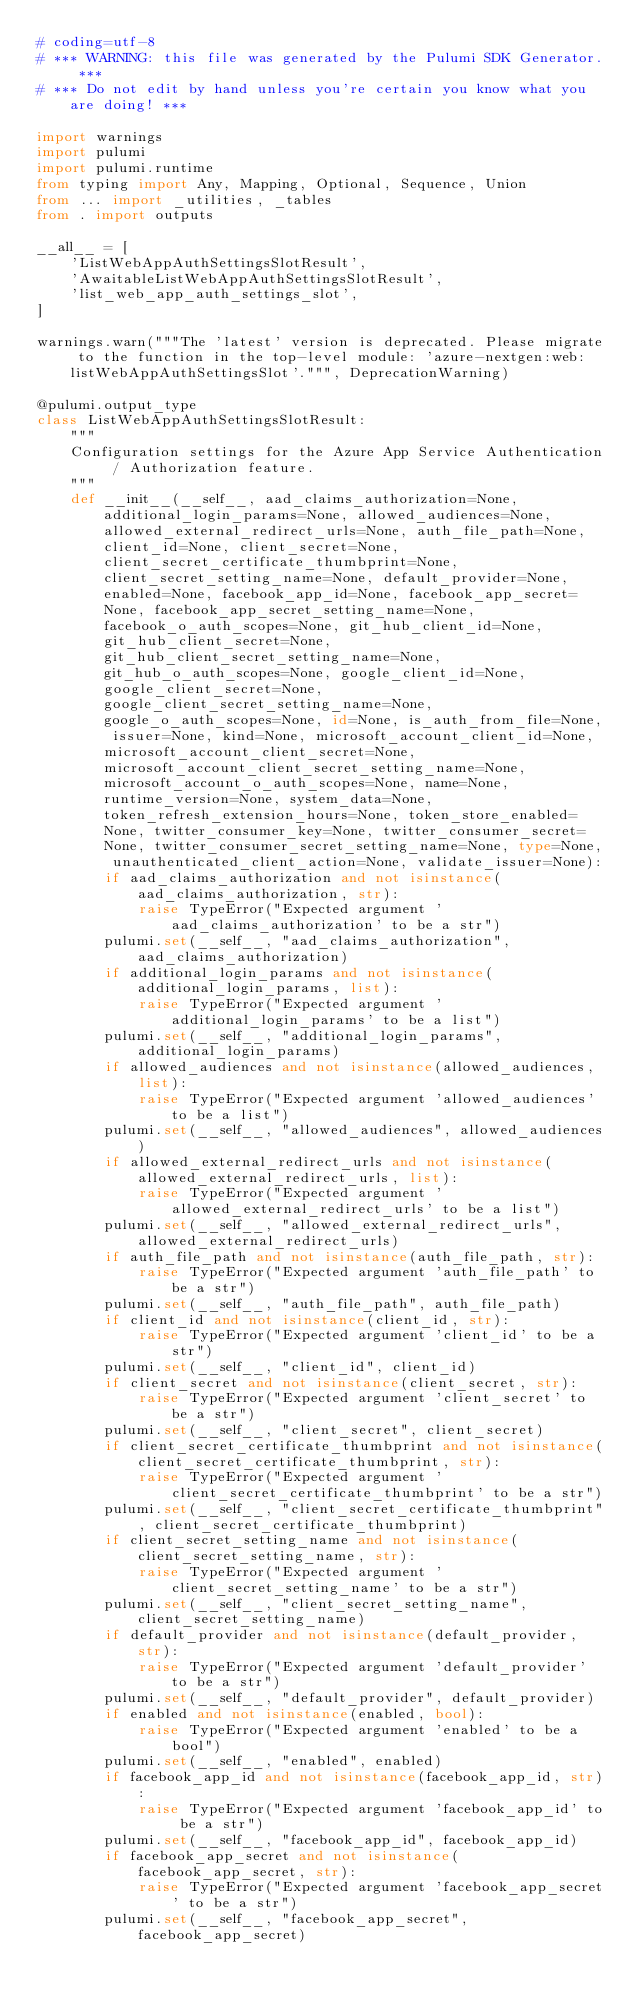<code> <loc_0><loc_0><loc_500><loc_500><_Python_># coding=utf-8
# *** WARNING: this file was generated by the Pulumi SDK Generator. ***
# *** Do not edit by hand unless you're certain you know what you are doing! ***

import warnings
import pulumi
import pulumi.runtime
from typing import Any, Mapping, Optional, Sequence, Union
from ... import _utilities, _tables
from . import outputs

__all__ = [
    'ListWebAppAuthSettingsSlotResult',
    'AwaitableListWebAppAuthSettingsSlotResult',
    'list_web_app_auth_settings_slot',
]

warnings.warn("""The 'latest' version is deprecated. Please migrate to the function in the top-level module: 'azure-nextgen:web:listWebAppAuthSettingsSlot'.""", DeprecationWarning)

@pulumi.output_type
class ListWebAppAuthSettingsSlotResult:
    """
    Configuration settings for the Azure App Service Authentication / Authorization feature.
    """
    def __init__(__self__, aad_claims_authorization=None, additional_login_params=None, allowed_audiences=None, allowed_external_redirect_urls=None, auth_file_path=None, client_id=None, client_secret=None, client_secret_certificate_thumbprint=None, client_secret_setting_name=None, default_provider=None, enabled=None, facebook_app_id=None, facebook_app_secret=None, facebook_app_secret_setting_name=None, facebook_o_auth_scopes=None, git_hub_client_id=None, git_hub_client_secret=None, git_hub_client_secret_setting_name=None, git_hub_o_auth_scopes=None, google_client_id=None, google_client_secret=None, google_client_secret_setting_name=None, google_o_auth_scopes=None, id=None, is_auth_from_file=None, issuer=None, kind=None, microsoft_account_client_id=None, microsoft_account_client_secret=None, microsoft_account_client_secret_setting_name=None, microsoft_account_o_auth_scopes=None, name=None, runtime_version=None, system_data=None, token_refresh_extension_hours=None, token_store_enabled=None, twitter_consumer_key=None, twitter_consumer_secret=None, twitter_consumer_secret_setting_name=None, type=None, unauthenticated_client_action=None, validate_issuer=None):
        if aad_claims_authorization and not isinstance(aad_claims_authorization, str):
            raise TypeError("Expected argument 'aad_claims_authorization' to be a str")
        pulumi.set(__self__, "aad_claims_authorization", aad_claims_authorization)
        if additional_login_params and not isinstance(additional_login_params, list):
            raise TypeError("Expected argument 'additional_login_params' to be a list")
        pulumi.set(__self__, "additional_login_params", additional_login_params)
        if allowed_audiences and not isinstance(allowed_audiences, list):
            raise TypeError("Expected argument 'allowed_audiences' to be a list")
        pulumi.set(__self__, "allowed_audiences", allowed_audiences)
        if allowed_external_redirect_urls and not isinstance(allowed_external_redirect_urls, list):
            raise TypeError("Expected argument 'allowed_external_redirect_urls' to be a list")
        pulumi.set(__self__, "allowed_external_redirect_urls", allowed_external_redirect_urls)
        if auth_file_path and not isinstance(auth_file_path, str):
            raise TypeError("Expected argument 'auth_file_path' to be a str")
        pulumi.set(__self__, "auth_file_path", auth_file_path)
        if client_id and not isinstance(client_id, str):
            raise TypeError("Expected argument 'client_id' to be a str")
        pulumi.set(__self__, "client_id", client_id)
        if client_secret and not isinstance(client_secret, str):
            raise TypeError("Expected argument 'client_secret' to be a str")
        pulumi.set(__self__, "client_secret", client_secret)
        if client_secret_certificate_thumbprint and not isinstance(client_secret_certificate_thumbprint, str):
            raise TypeError("Expected argument 'client_secret_certificate_thumbprint' to be a str")
        pulumi.set(__self__, "client_secret_certificate_thumbprint", client_secret_certificate_thumbprint)
        if client_secret_setting_name and not isinstance(client_secret_setting_name, str):
            raise TypeError("Expected argument 'client_secret_setting_name' to be a str")
        pulumi.set(__self__, "client_secret_setting_name", client_secret_setting_name)
        if default_provider and not isinstance(default_provider, str):
            raise TypeError("Expected argument 'default_provider' to be a str")
        pulumi.set(__self__, "default_provider", default_provider)
        if enabled and not isinstance(enabled, bool):
            raise TypeError("Expected argument 'enabled' to be a bool")
        pulumi.set(__self__, "enabled", enabled)
        if facebook_app_id and not isinstance(facebook_app_id, str):
            raise TypeError("Expected argument 'facebook_app_id' to be a str")
        pulumi.set(__self__, "facebook_app_id", facebook_app_id)
        if facebook_app_secret and not isinstance(facebook_app_secret, str):
            raise TypeError("Expected argument 'facebook_app_secret' to be a str")
        pulumi.set(__self__, "facebook_app_secret", facebook_app_secret)</code> 